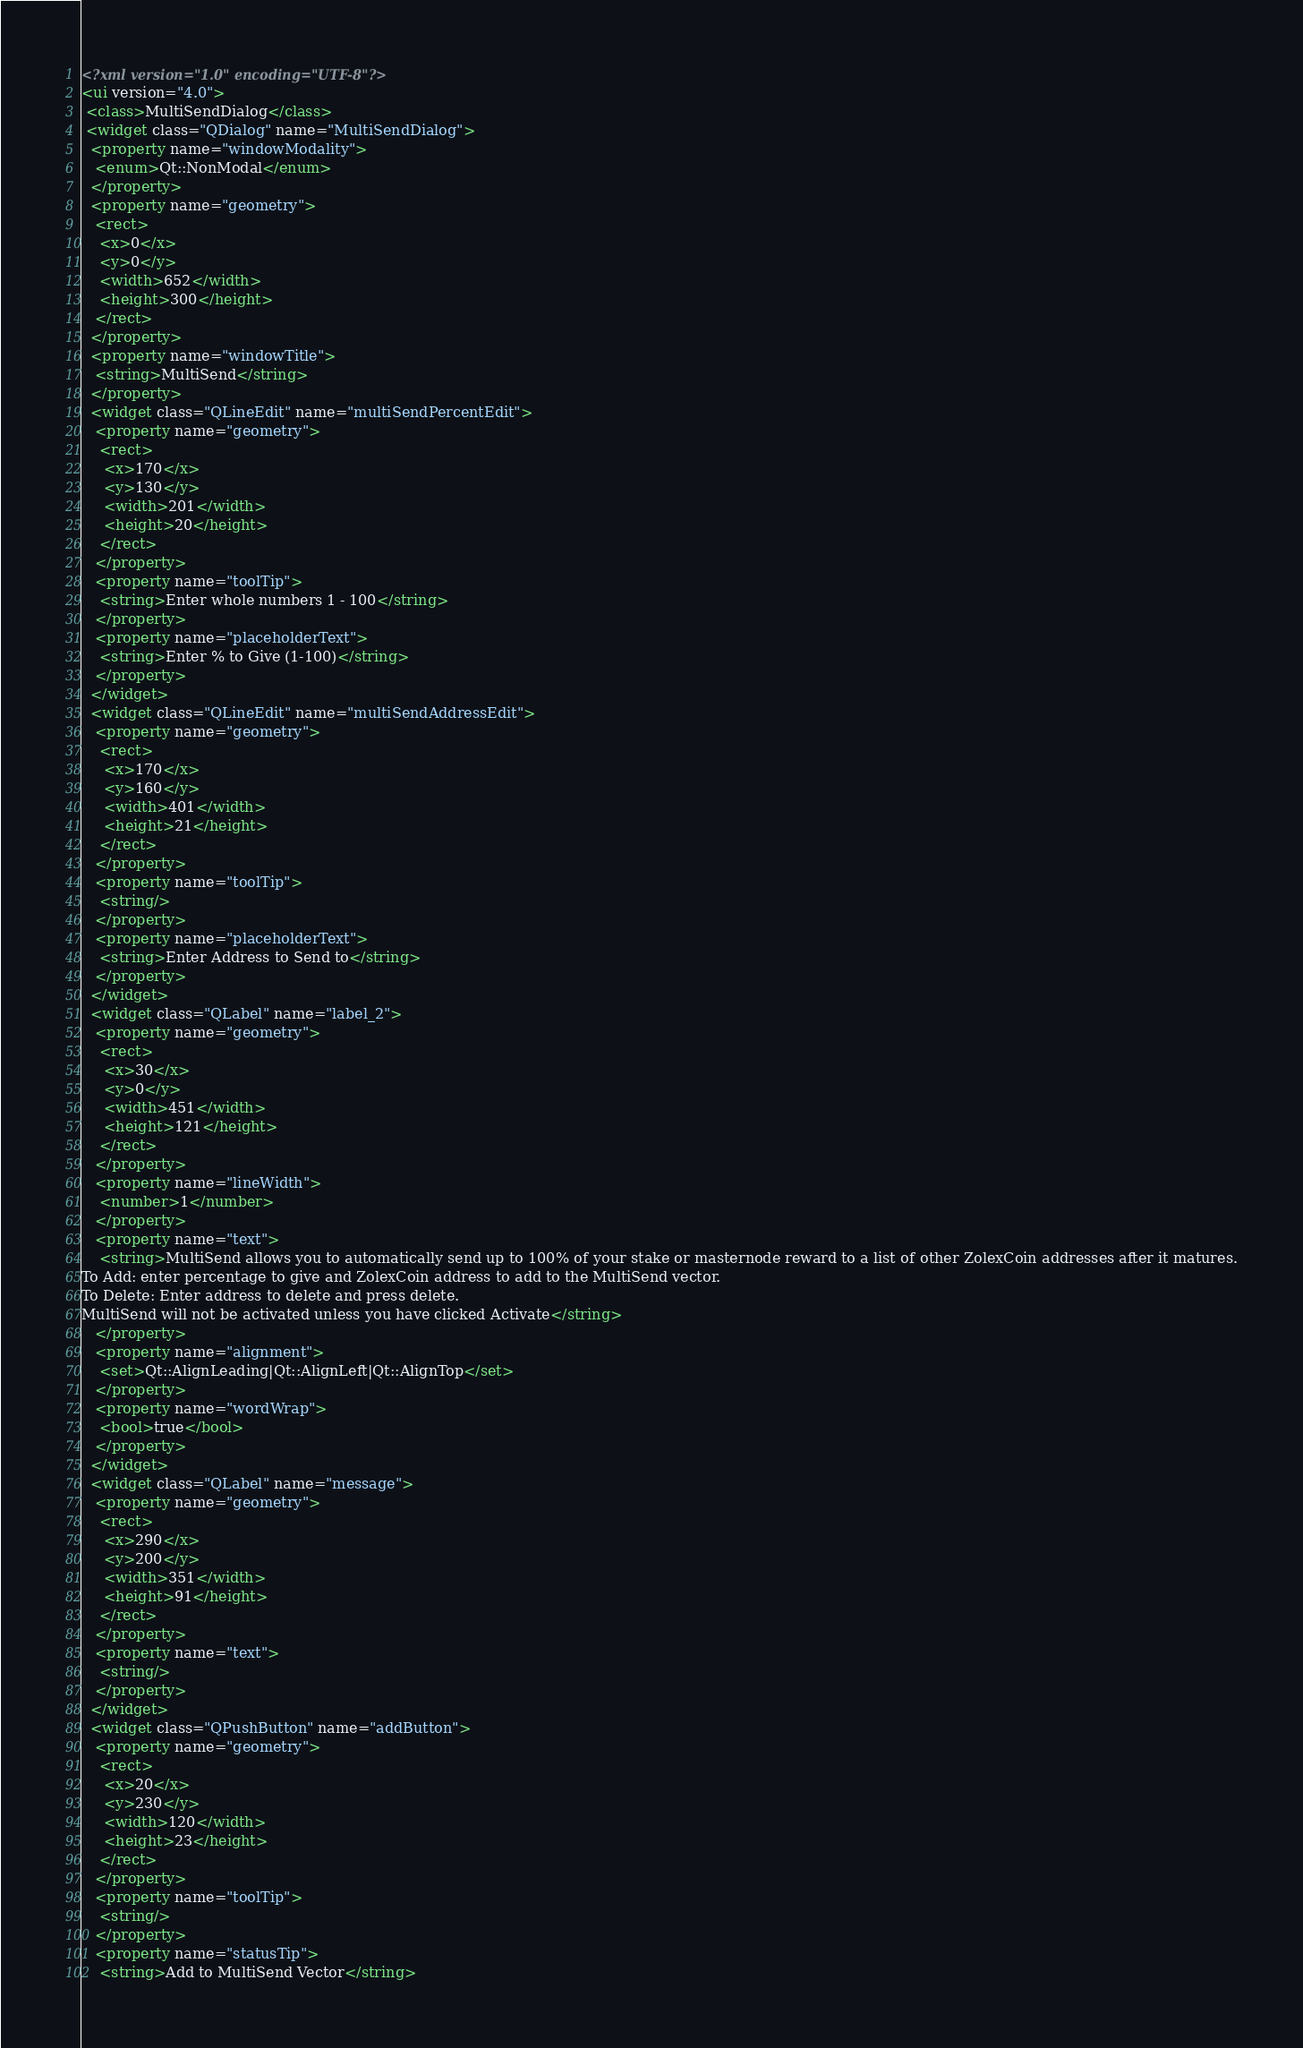<code> <loc_0><loc_0><loc_500><loc_500><_XML_><?xml version="1.0" encoding="UTF-8"?>
<ui version="4.0">
 <class>MultiSendDialog</class>
 <widget class="QDialog" name="MultiSendDialog">
  <property name="windowModality">
   <enum>Qt::NonModal</enum>
  </property>
  <property name="geometry">
   <rect>
    <x>0</x>
    <y>0</y>
    <width>652</width>
    <height>300</height>
   </rect>
  </property>
  <property name="windowTitle">
   <string>MultiSend</string>
  </property>
  <widget class="QLineEdit" name="multiSendPercentEdit">
   <property name="geometry">
    <rect>
     <x>170</x>
     <y>130</y>
     <width>201</width>
     <height>20</height>
    </rect>
   </property>
   <property name="toolTip">
    <string>Enter whole numbers 1 - 100</string>
   </property>
   <property name="placeholderText">
    <string>Enter % to Give (1-100)</string>
   </property>
  </widget>
  <widget class="QLineEdit" name="multiSendAddressEdit">
   <property name="geometry">
    <rect>
     <x>170</x>
     <y>160</y>
     <width>401</width>
     <height>21</height>
    </rect>
   </property>
   <property name="toolTip">
    <string/>
   </property>
   <property name="placeholderText">
    <string>Enter Address to Send to</string>
   </property>
  </widget>
  <widget class="QLabel" name="label_2">
   <property name="geometry">
    <rect>
     <x>30</x>
     <y>0</y>
     <width>451</width>
     <height>121</height>
    </rect>
   </property>
   <property name="lineWidth">
    <number>1</number>
   </property>
   <property name="text">
    <string>MultiSend allows you to automatically send up to 100% of your stake or masternode reward to a list of other ZolexCoin addresses after it matures.
To Add: enter percentage to give and ZolexCoin address to add to the MultiSend vector.
To Delete: Enter address to delete and press delete.
MultiSend will not be activated unless you have clicked Activate</string>
   </property>
   <property name="alignment">
    <set>Qt::AlignLeading|Qt::AlignLeft|Qt::AlignTop</set>
   </property>
   <property name="wordWrap">
    <bool>true</bool>
   </property>
  </widget>
  <widget class="QLabel" name="message">
   <property name="geometry">
    <rect>
     <x>290</x>
     <y>200</y>
     <width>351</width>
     <height>91</height>
    </rect>
   </property>
   <property name="text">
    <string/>
   </property>
  </widget>
  <widget class="QPushButton" name="addButton">
   <property name="geometry">
    <rect>
     <x>20</x>
     <y>230</y>
     <width>120</width>
     <height>23</height>
    </rect>
   </property>
   <property name="toolTip">
    <string/>
   </property>
   <property name="statusTip">
    <string>Add to MultiSend Vector</string></code> 